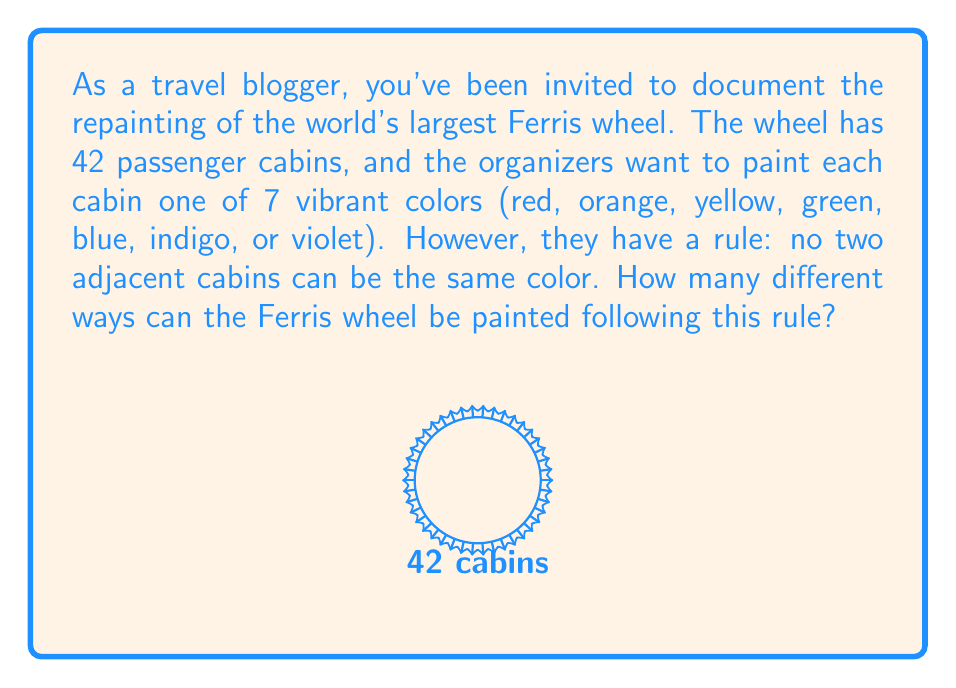Can you answer this question? Let's approach this step-by-step:

1) This problem can be solved using the multiplication principle and circular permutations.

2) For the first cabin, we have 7 color choices.

3) For each subsequent cabin, we have 6 choices (all colors except the one used for the previous cabin).

4) However, we need to consider that this is a circular arrangement. The last cabin must also be a different color from the first one.

5) To account for this, we can use the following method:
   - Choose colors for 41 cabins (leaving the last one)
   - For the last cabin, we'll have 5 choices (all colors except those of the first and the 41st cabins)

6) Therefore, the total number of ways to paint the Ferris wheel is:

   $$7 \times 6^{40} \times 5$$

7) This can be simplified as:

   $$7 \times 5 \times 6^{40} = 35 \times 6^{40}$$

8) Computing this:
   $$35 \times 6^{40} = 35 \times 13367494538843734067838845976576$$

9) The final result is a very large number:

   $$467862308859530692374359609180160$$
Answer: $35 \times 6^{40}$ or $467862308859530692374359609180160$ 